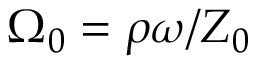Convert formula to latex. <formula><loc_0><loc_0><loc_500><loc_500>\Omega _ { 0 } = \rho \omega / Z _ { 0 }</formula> 